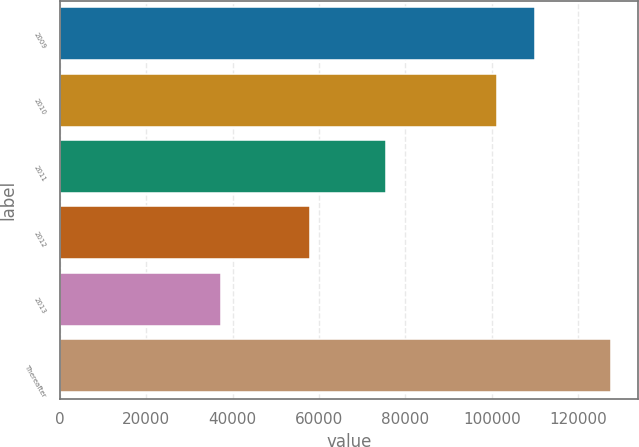Convert chart to OTSL. <chart><loc_0><loc_0><loc_500><loc_500><bar_chart><fcel>2009<fcel>2010<fcel>2011<fcel>2012<fcel>2013<fcel>Thereafter<nl><fcel>110109<fcel>101084<fcel>75467<fcel>57827<fcel>37324<fcel>127577<nl></chart> 